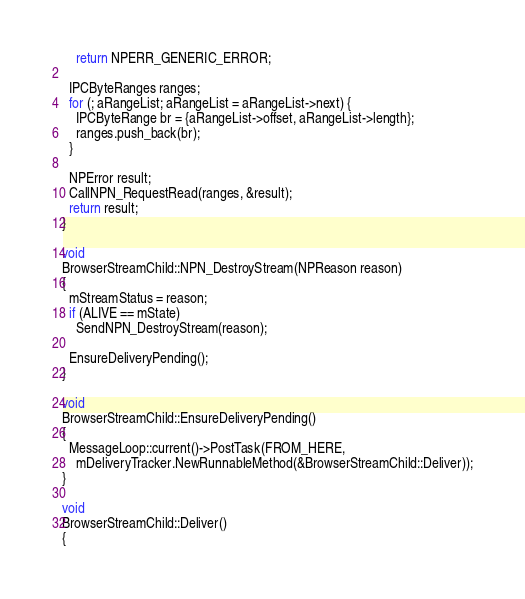<code> <loc_0><loc_0><loc_500><loc_500><_C++_>    return NPERR_GENERIC_ERROR;

  IPCByteRanges ranges;
  for (; aRangeList; aRangeList = aRangeList->next) {
    IPCByteRange br = {aRangeList->offset, aRangeList->length};
    ranges.push_back(br);
  }

  NPError result;
  CallNPN_RequestRead(ranges, &result);
  return result;
}

void
BrowserStreamChild::NPN_DestroyStream(NPReason reason)
{
  mStreamStatus = reason;
  if (ALIVE == mState)
    SendNPN_DestroyStream(reason);

  EnsureDeliveryPending();
}

void
BrowserStreamChild::EnsureDeliveryPending()
{
  MessageLoop::current()->PostTask(FROM_HERE,
    mDeliveryTracker.NewRunnableMethod(&BrowserStreamChild::Deliver));
}

void
BrowserStreamChild::Deliver()
{</code> 